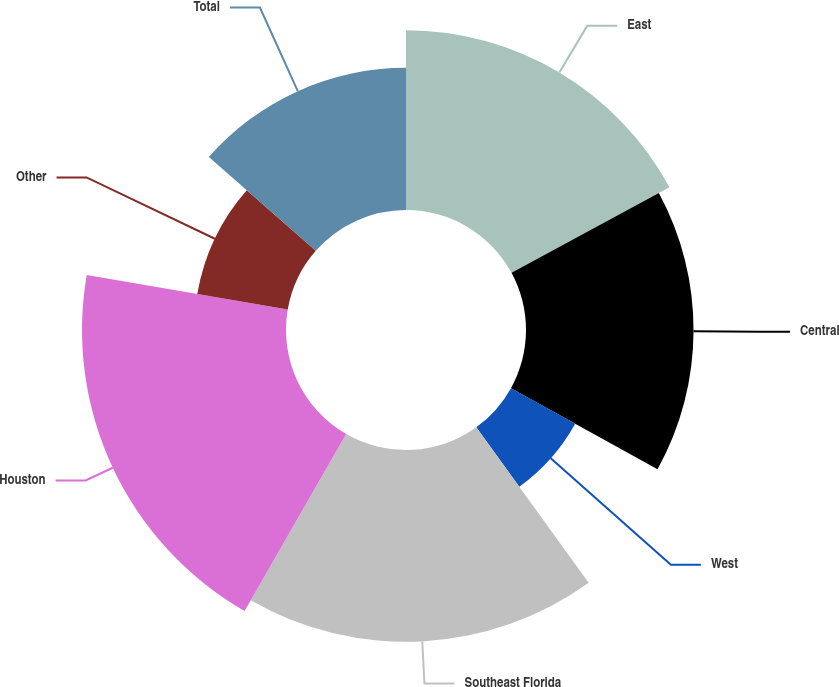Convert chart. <chart><loc_0><loc_0><loc_500><loc_500><pie_chart><fcel>East<fcel>Central<fcel>West<fcel>Southeast Florida<fcel>Houston<fcel>Other<fcel>Total<nl><fcel>17.1%<fcel>15.95%<fcel>6.99%<fcel>18.26%<fcel>19.42%<fcel>8.74%<fcel>13.54%<nl></chart> 